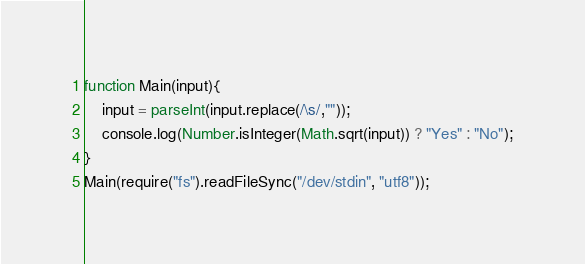Convert code to text. <code><loc_0><loc_0><loc_500><loc_500><_JavaScript_>function Main(input){
    input = parseInt(input.replace(/\s/,""));
  	console.log(Number.isInteger(Math.sqrt(input)) ? "Yes" : "No");
}
Main(require("fs").readFileSync("/dev/stdin", "utf8"));</code> 